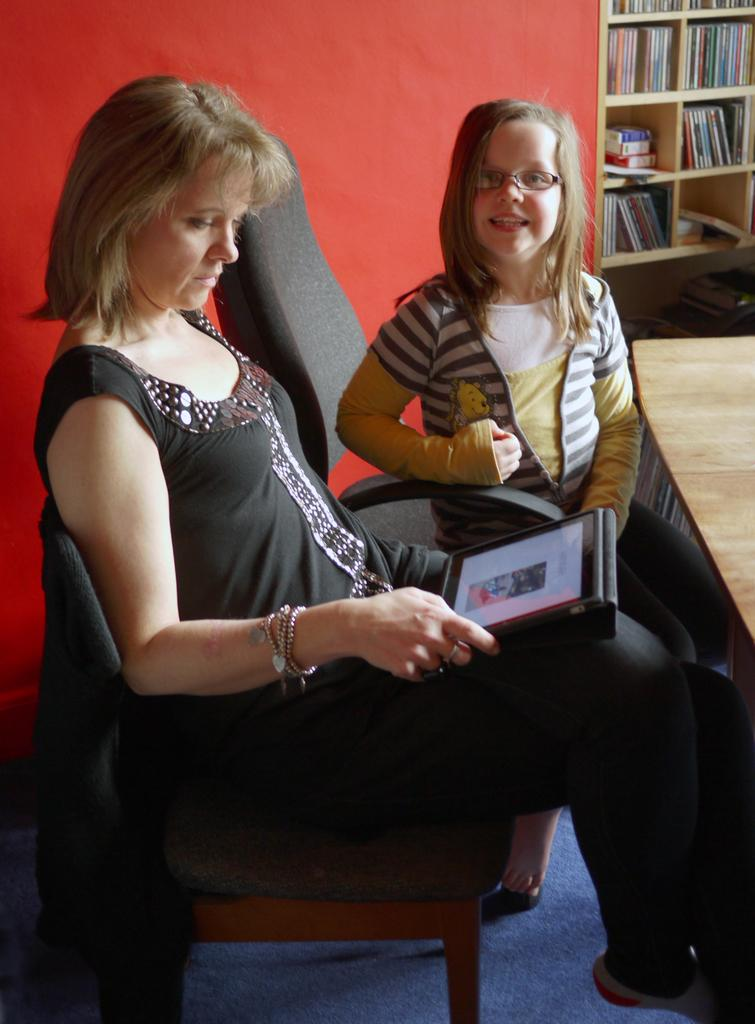How many women are in the image? There are two women in the image. What are the women doing in the image? The women are sitting on chairs. What is in front of the women? There is a table in front of the women. What can be seen on the wall behind the women? There is a bookshelf with books in the image. What type of basin is visible on the table in the image? There is no basin present on the table in the image. What treatment are the women receiving in the image? The image does not depict any treatment being administered to the women. 